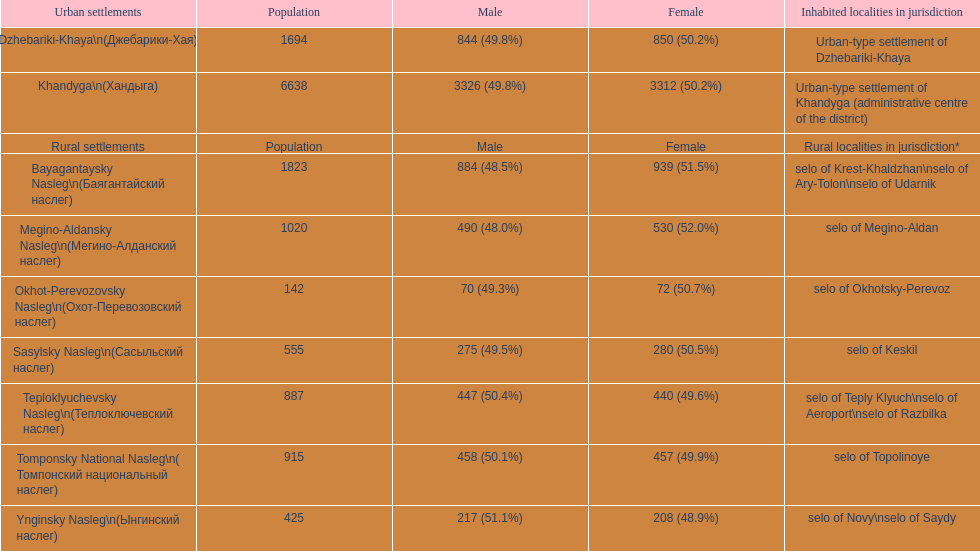What is the total population in dzhebariki-khaya? 1694. 